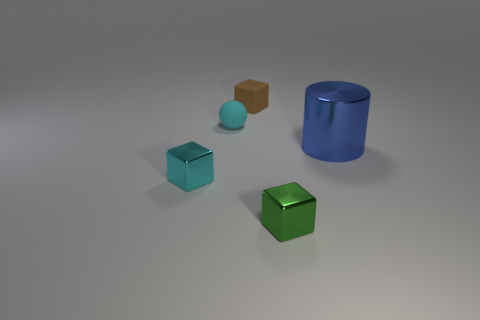Can you describe the objects in this image and their respective positions? Certainly! There are four objects in this image. Starting from the left, there's a small brown cube, a small cyan sphere, a medium-sized cyan cube, and a large green cube. Close to the right side, there's a single large shiny blue cylinder. The objects are placed on a reflective surface, suggesting an indoor setting with neutral lighting. 